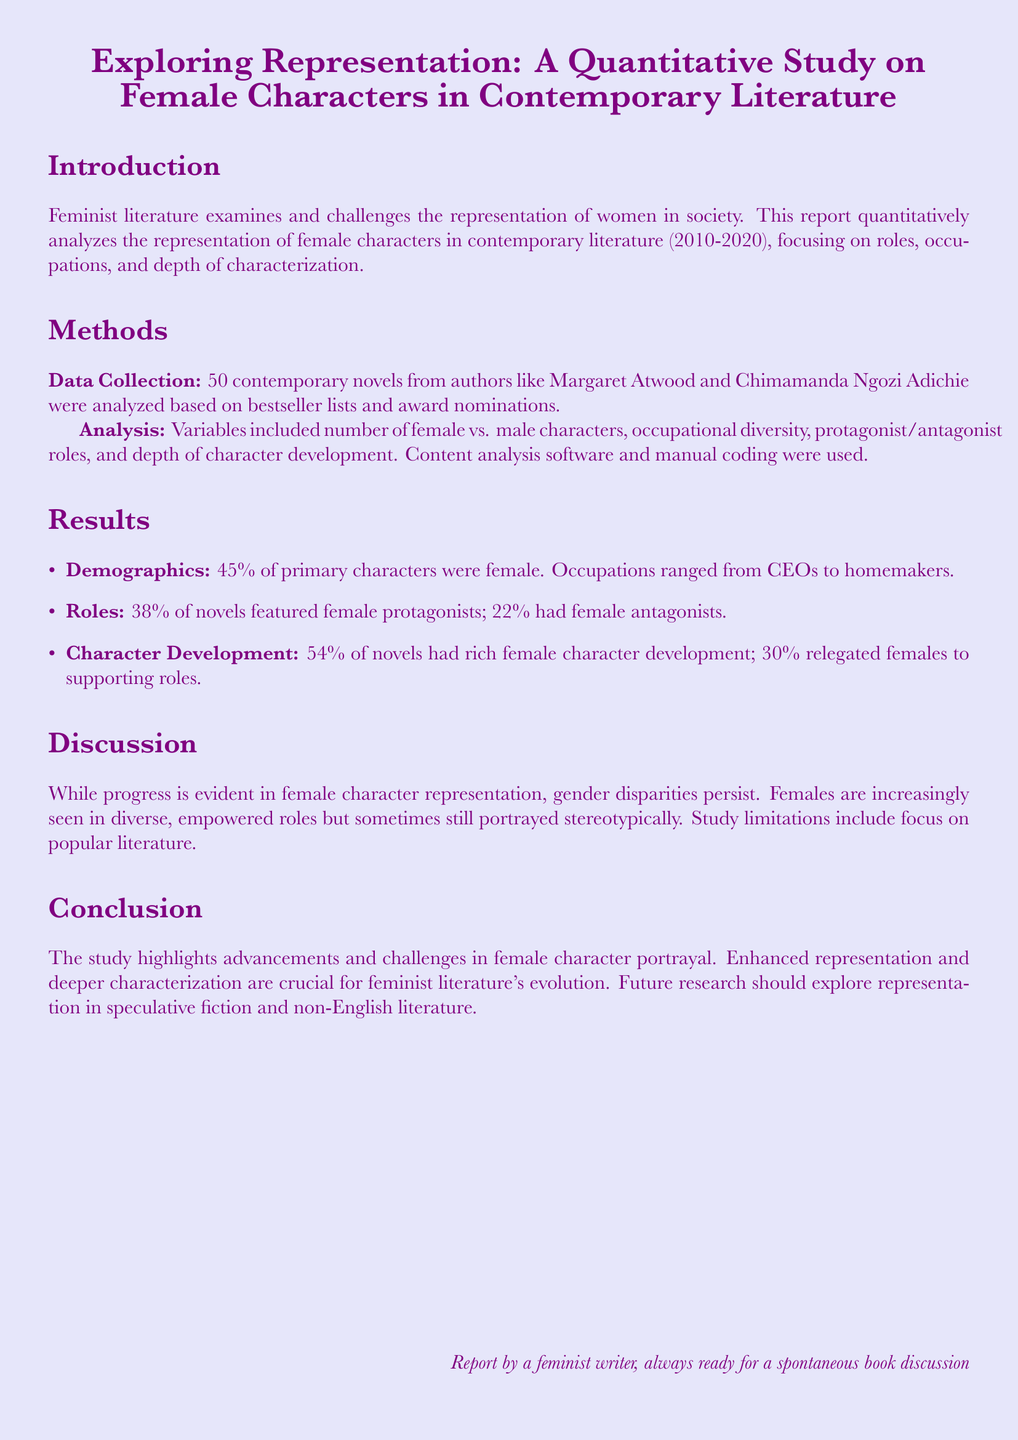What is the percentage of primary characters that were female? The percentage reflects the proportion of female characters among primary characters, which is provided in the results section.
Answer: 45% What is the percentage of novels featuring female protagonists? The percentage indicates how many of the analyzed novels had female protagonists, as stated in the results.
Answer: 38% Which authors' works were included in the analysis? The authors mentioned reflect the selection criteria for the titles analyzed in the study, found in the methods section.
Answer: Margaret Atwood and Chimamanda Ngozi Adichie What proportion of novels had rich female character development? The proportion shows how many novels focused on substantial character development for female characters, detailed in the results section.
Answer: 54% What was a limitation of the study mentioned in the discussion? The limitation relates to the scope of literature analyzed, explaining potential shortcomings in generalizability of the findings, noted in the discussion.
Answer: Focus on popular literature How many novels had female antagonists? The number reflects how many of the analyzed novels included female characters in antagonistic roles, specified in the results section.
Answer: 22% What period did the study focus on? The period establishes the timeframe for the literature analyzed, found in the introduction.
Answer: 2010-2020 What is the overall conclusion of the study regarding female character portrayal? The conclusion synthesizes the findings about advancements and ongoing challenges in female representation in literature.
Answer: Advancements and challenges What kind of analysis was used in the study? The type of analysis refers to the methods utilized to examine the data, indicated in the methods section.
Answer: Content analysis 